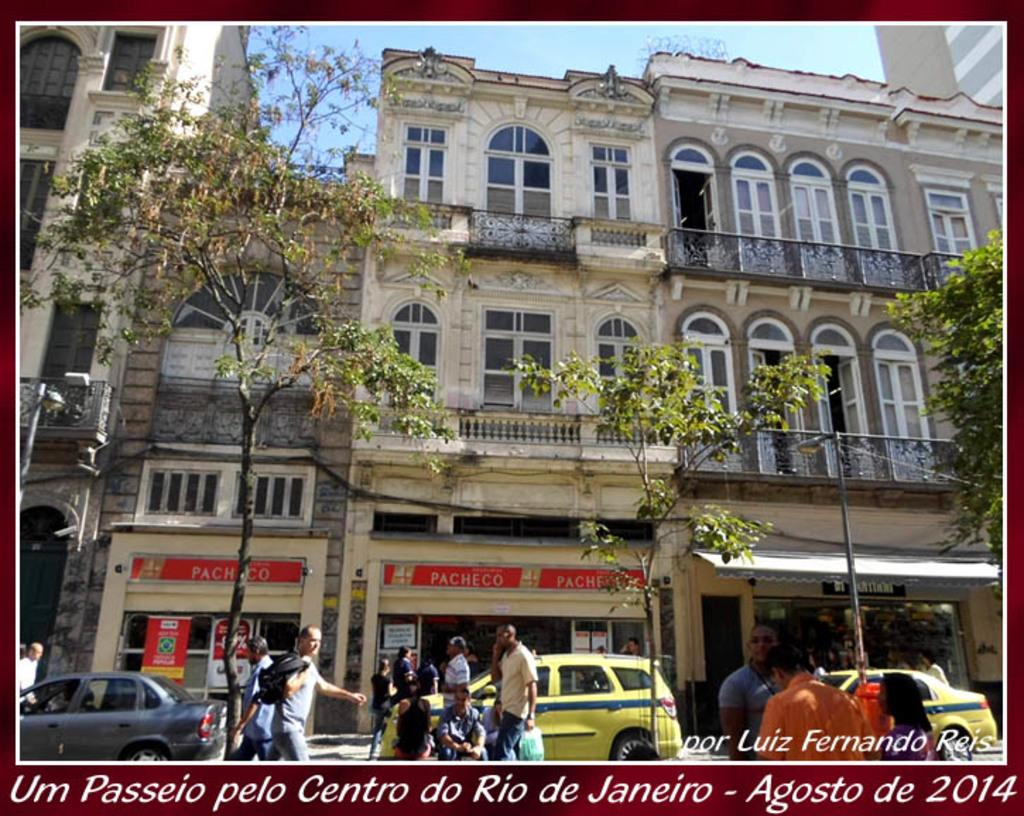<image>
Relay a brief, clear account of the picture shown. A photograph of some buildings in Rio de Janeiro was taken in 2014. 